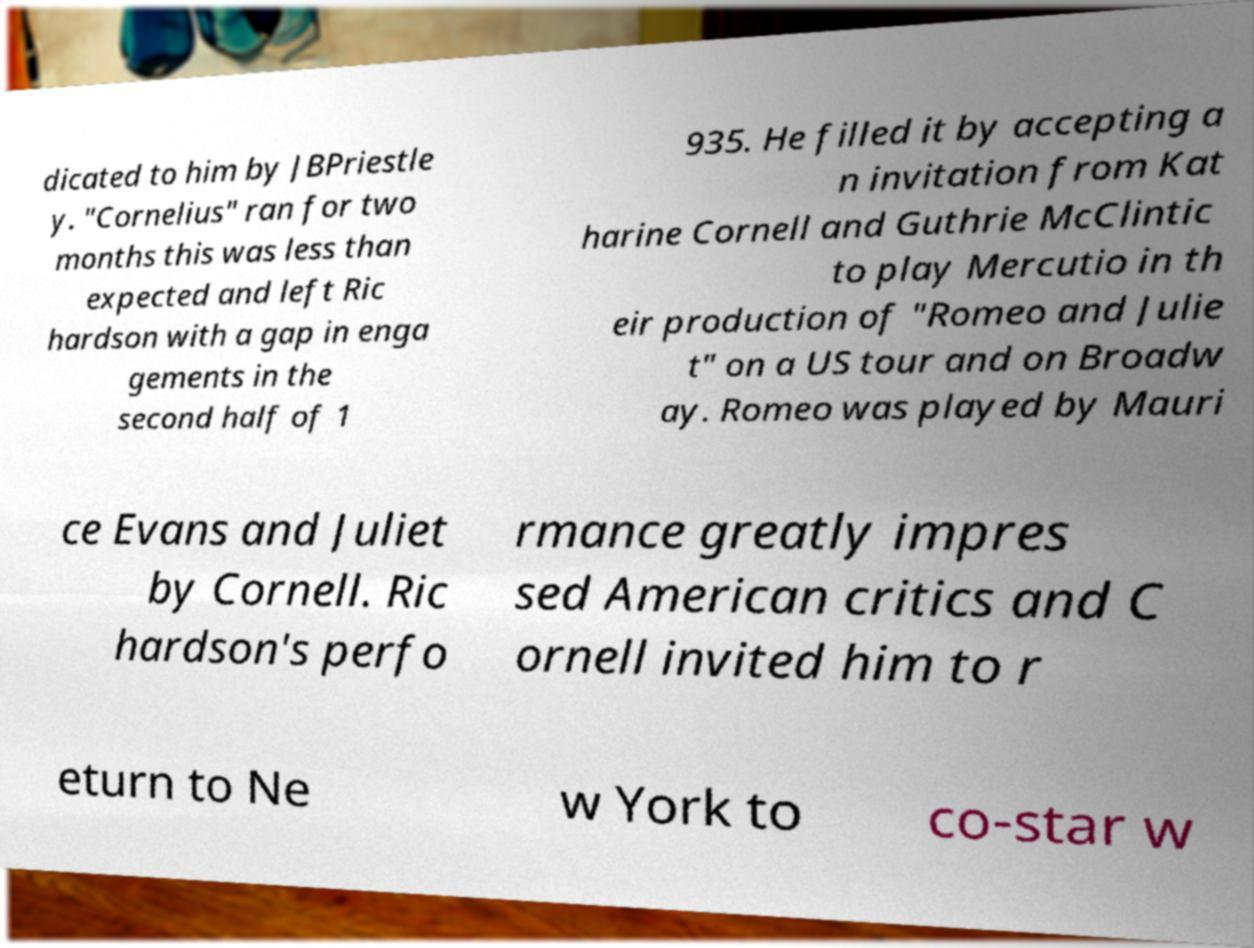Can you read and provide the text displayed in the image?This photo seems to have some interesting text. Can you extract and type it out for me? dicated to him by JBPriestle y. "Cornelius" ran for two months this was less than expected and left Ric hardson with a gap in enga gements in the second half of 1 935. He filled it by accepting a n invitation from Kat harine Cornell and Guthrie McClintic to play Mercutio in th eir production of "Romeo and Julie t" on a US tour and on Broadw ay. Romeo was played by Mauri ce Evans and Juliet by Cornell. Ric hardson's perfo rmance greatly impres sed American critics and C ornell invited him to r eturn to Ne w York to co-star w 